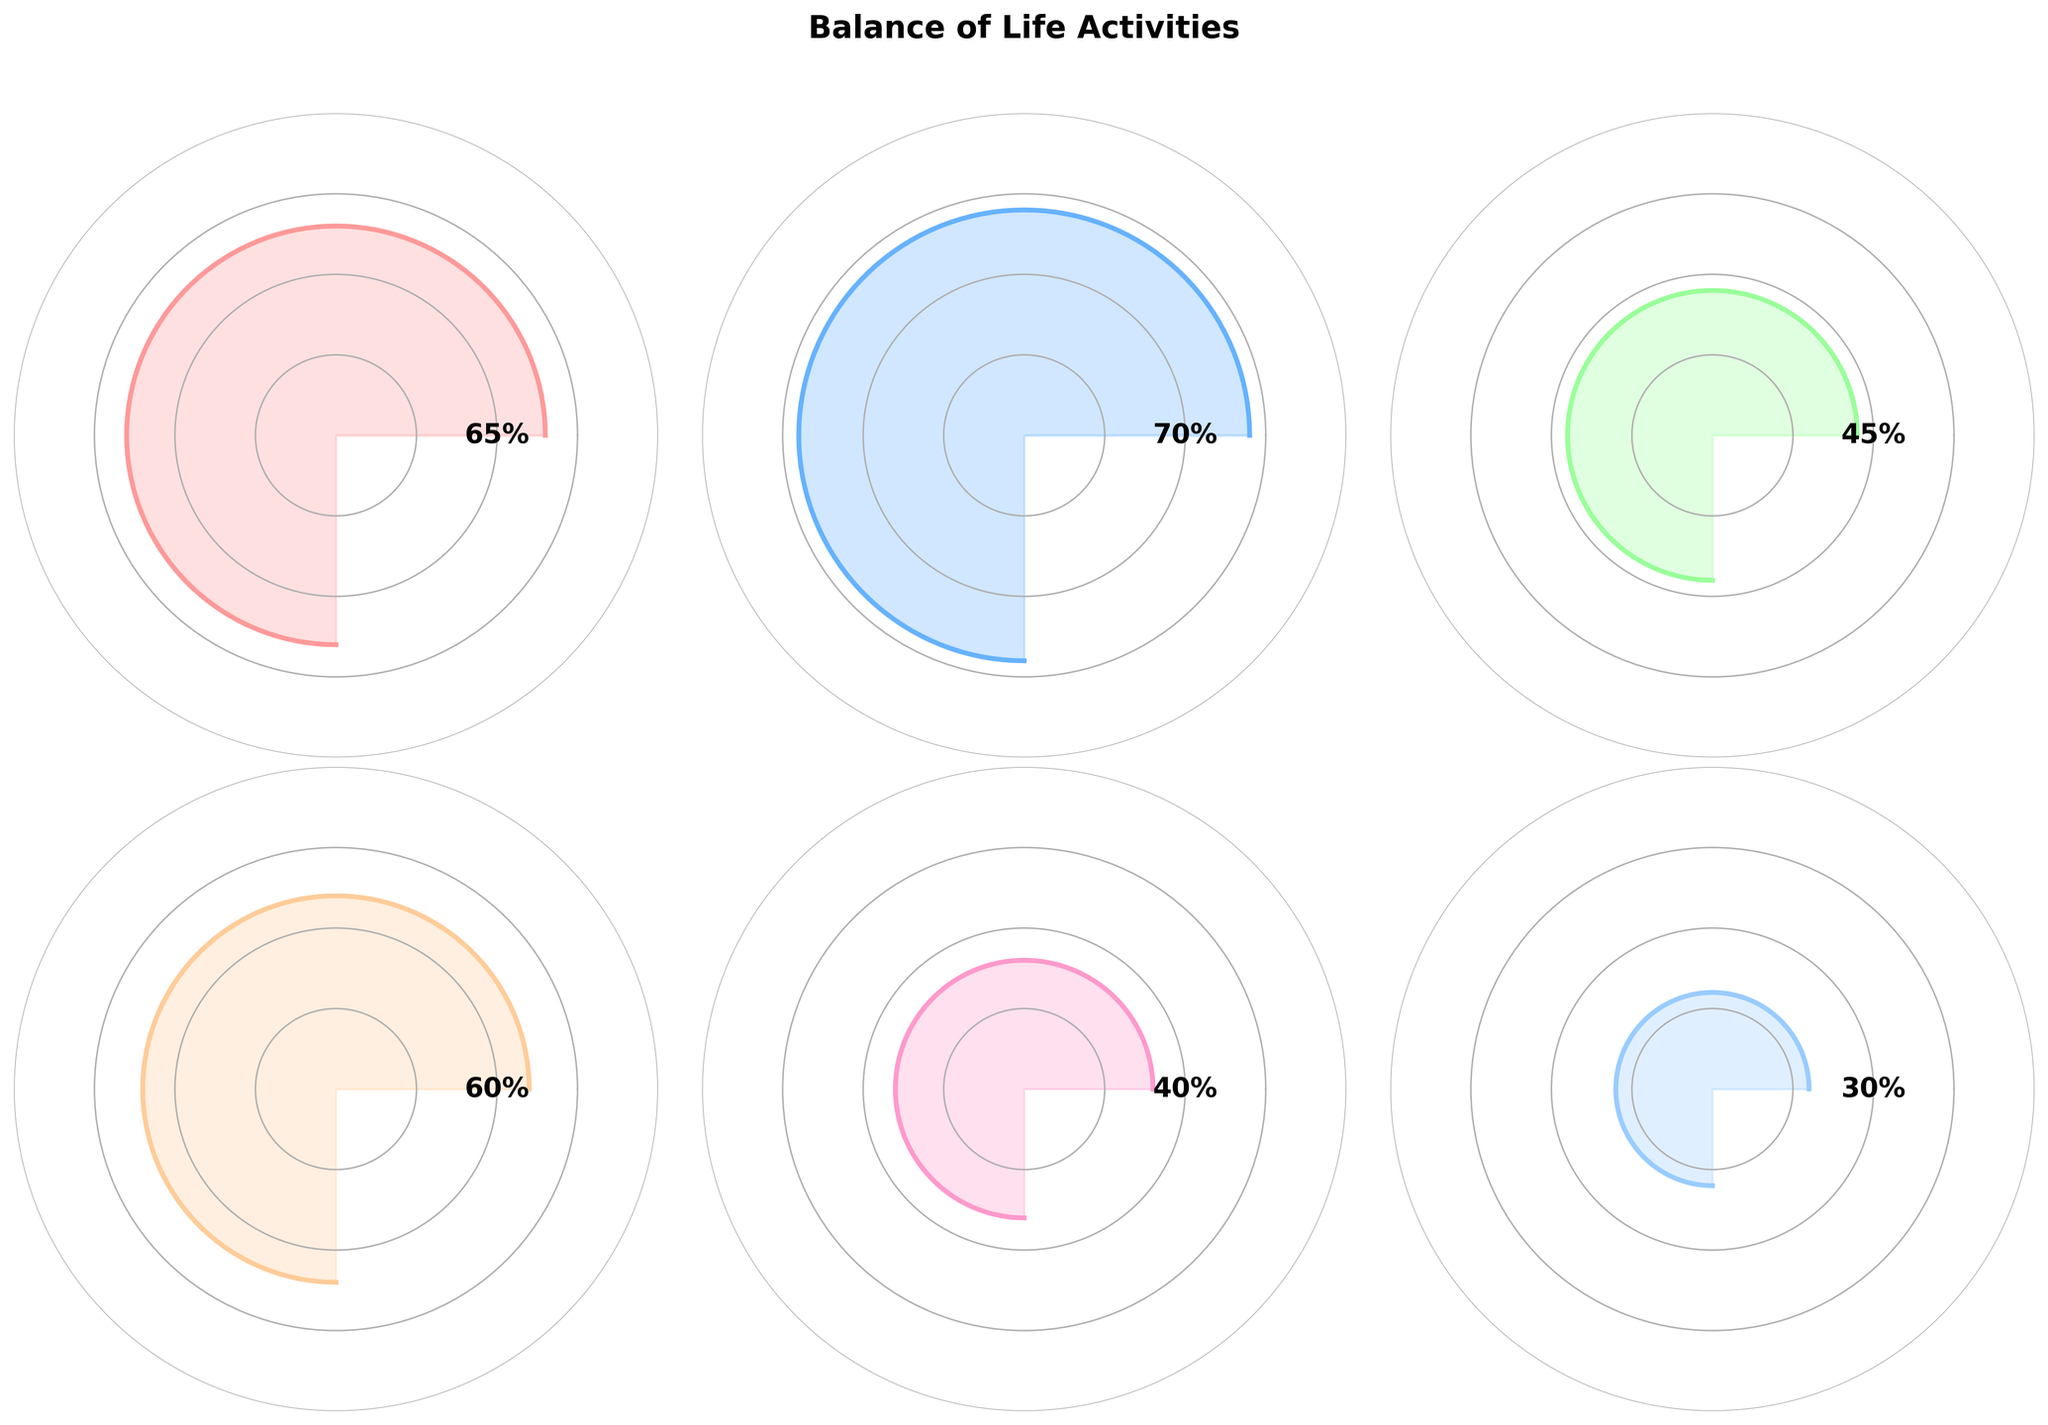what is the title of the figure? The title of the figure is displayed clearly at the top. It reads "Balance of Life Activities".
Answer: Balance of Life Activities How many categories are visualized in this figure? By counting the number of gauge charts, you can see that there are six categories represented.
Answer: Six What is the value for "Personal Time"? By looking at the gauge chart labeled "Personal Time", the value shown is 45%.
Answer: 45% Which category has the highest value? By comparing the values in each gauge chart, it is clear that "Work Hours" has the highest value at 70%.
Answer: Work Hours What is the difference between the value of "Judo Training" and "Family Time"? The value for "Judo Training" is 65% and for "Family Time" is 40%. The difference is calculated as 65 - 40.
Answer: 25% Which two categories have the closest values and what are they? By comparing the values, "Sleep" at 60% and "Judo Training" at 65% are the closest. The difference is just 5%.
Answer: Sleep and Judo Training What is the average value of all the categories? Adding up all the values (65+70+45+60+40+30) gives 310. Dividing by the number of categories (6) gives an average value of 51.67%.
Answer: 51.67% Which category is represented with the color that is most distinctively different from the colors used for the other categories? The "Meditation" category appears with a lighter shade compared to the more vivid colors used for others.
Answer: Meditation If I want to balance the time for "Personal Time" and "Family Time" equally, how much should I adjust each (assuming the total time for these two remains the same)? The total time for "Personal Time" and "Family Time" is 45 + 40 = 85%. To balance the time equally, each should get half of this total. So, 85/2 = 42.5%.
Answer: 42.5% Is the time spent on "Meditation" more or less than half of the time spent on "Work Hours"? The value for "Meditation" is 30%, and half of the "Work Hours" value (70%) is 35%. Since 30% is less than 35%, "Meditation" time is less.
Answer: Less 